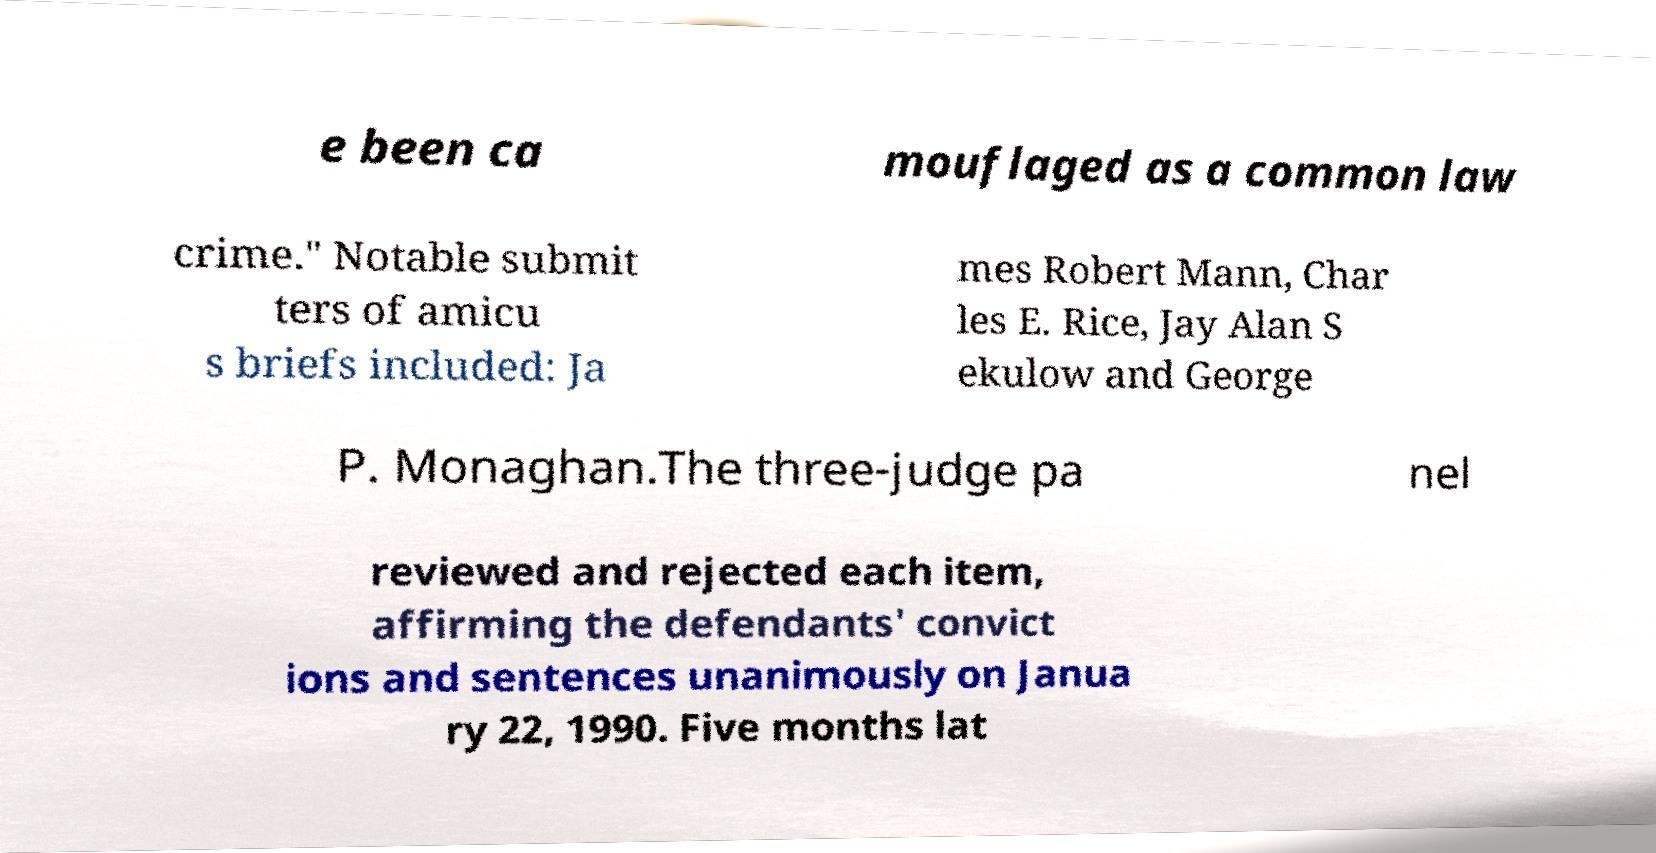I need the written content from this picture converted into text. Can you do that? e been ca mouflaged as a common law crime." Notable submit ters of amicu s briefs included: Ja mes Robert Mann, Char les E. Rice, Jay Alan S ekulow and George P. Monaghan.The three-judge pa nel reviewed and rejected each item, affirming the defendants' convict ions and sentences unanimously on Janua ry 22, 1990. Five months lat 